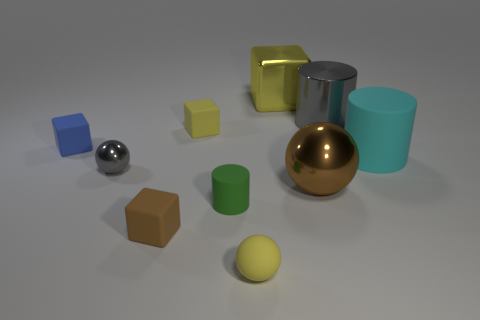Is there any other thing that has the same size as the metallic cylinder?
Offer a terse response. Yes. There is a cylinder that is the same material as the cyan thing; what color is it?
Your answer should be compact. Green. There is another thing that is the same color as the tiny metal object; what material is it?
Give a very brief answer. Metal. Is there a small matte sphere that has the same color as the big cube?
Your response must be concise. Yes. What is the shape of the tiny rubber object that is both right of the brown block and behind the tiny rubber cylinder?
Provide a succinct answer. Cube. How many large brown balls have the same material as the large yellow cube?
Offer a terse response. 1. Are there fewer blue objects that are behind the tiny cylinder than yellow objects that are in front of the gray metallic cylinder?
Your response must be concise. Yes. There is a gray thing that is in front of the rubber cube that is on the left side of the small gray thing that is behind the small rubber cylinder; what is it made of?
Your answer should be very brief. Metal. There is a object that is behind the tiny brown matte object and in front of the big metallic ball; what size is it?
Provide a succinct answer. Small. What number of cylinders are yellow matte things or green objects?
Ensure brevity in your answer.  1. 